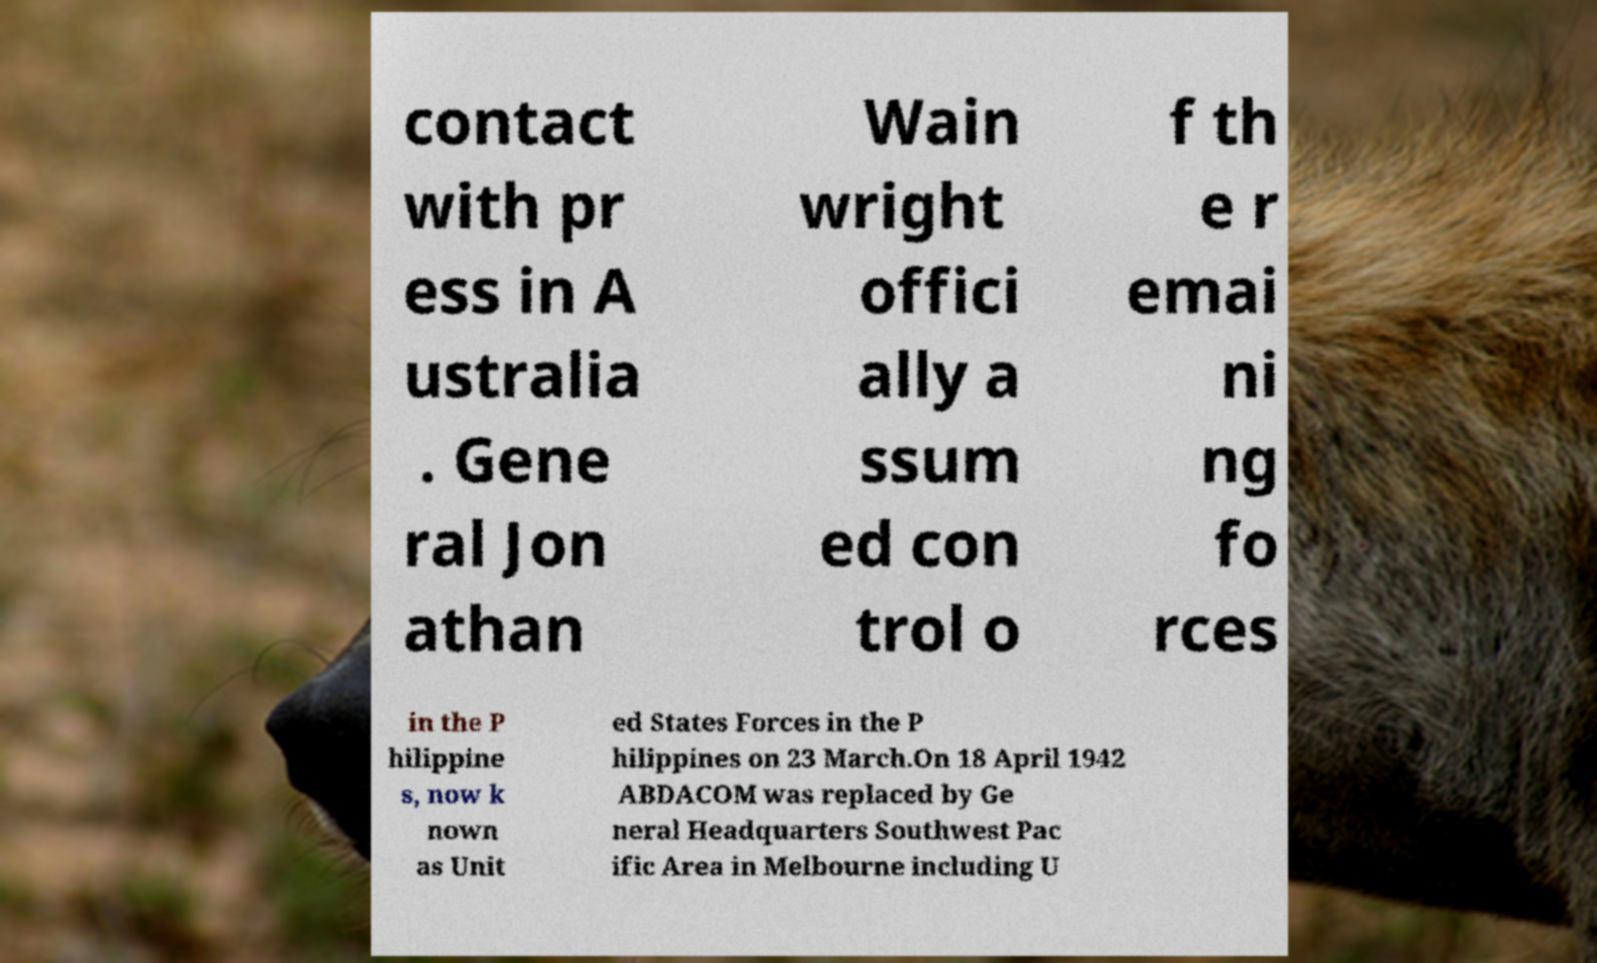For documentation purposes, I need the text within this image transcribed. Could you provide that? contact with pr ess in A ustralia . Gene ral Jon athan Wain wright offici ally a ssum ed con trol o f th e r emai ni ng fo rces in the P hilippine s, now k nown as Unit ed States Forces in the P hilippines on 23 March.On 18 April 1942 ABDACOM was replaced by Ge neral Headquarters Southwest Pac ific Area in Melbourne including U 